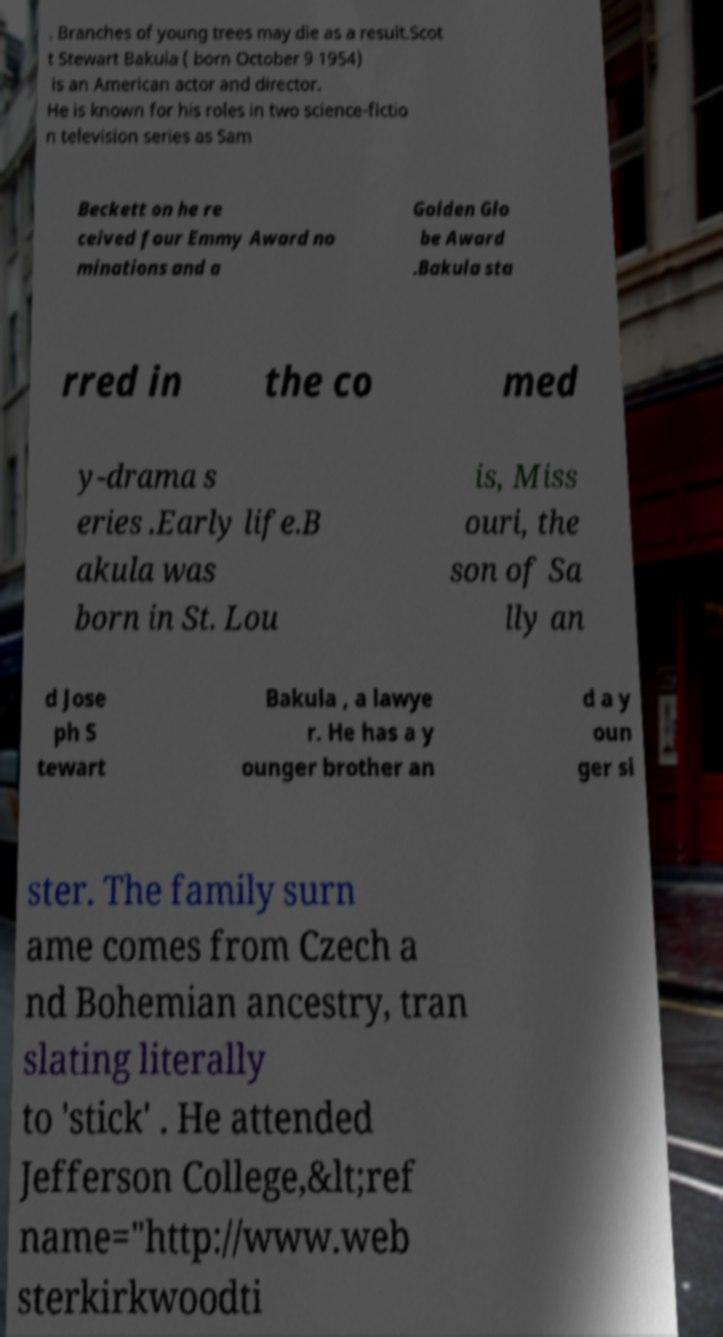Can you read and provide the text displayed in the image?This photo seems to have some interesting text. Can you extract and type it out for me? . Branches of young trees may die as a result.Scot t Stewart Bakula ( born October 9 1954) is an American actor and director. He is known for his roles in two science-fictio n television series as Sam Beckett on he re ceived four Emmy Award no minations and a Golden Glo be Award .Bakula sta rred in the co med y-drama s eries .Early life.B akula was born in St. Lou is, Miss ouri, the son of Sa lly an d Jose ph S tewart Bakula , a lawye r. He has a y ounger brother an d a y oun ger si ster. The family surn ame comes from Czech a nd Bohemian ancestry, tran slating literally to 'stick' . He attended Jefferson College,&lt;ref name="http://www.web sterkirkwoodti 